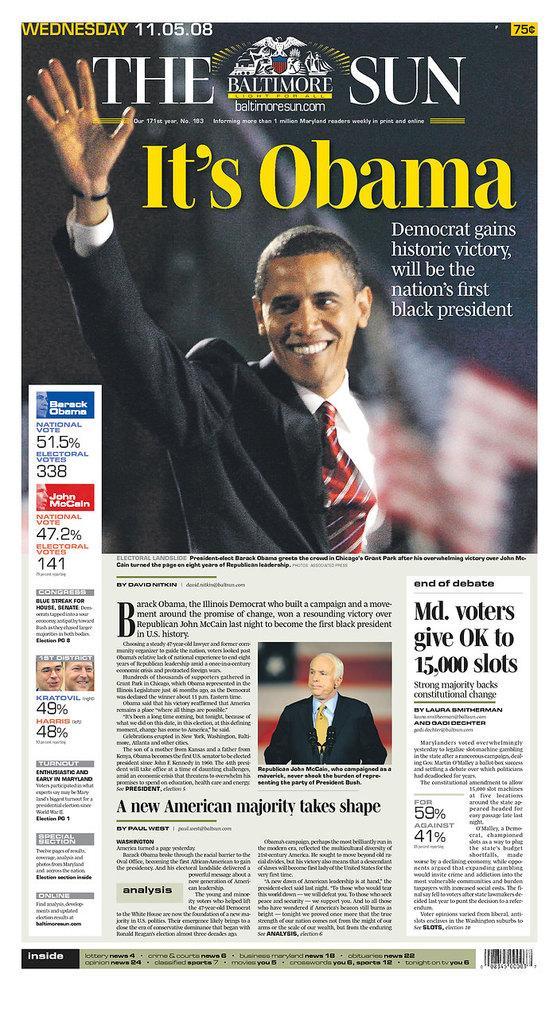Can you describe this image briefly? In this image we can see poster with text and images of persons. 